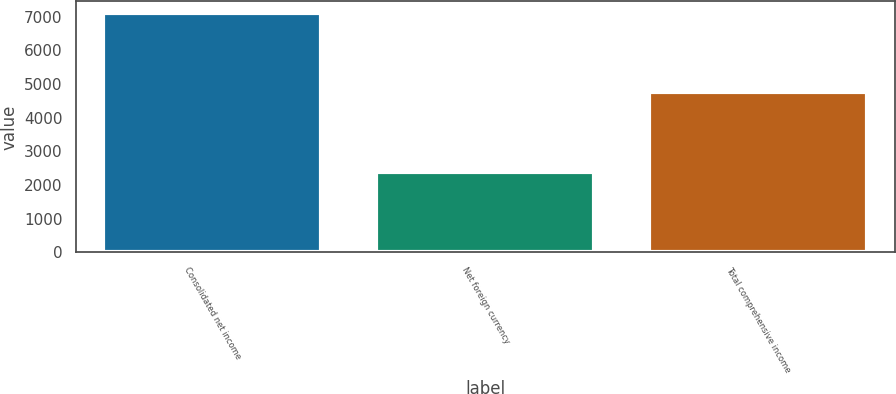Convert chart. <chart><loc_0><loc_0><loc_500><loc_500><bar_chart><fcel>Consolidated net income<fcel>Net foreign currency<fcel>Total comprehensive income<nl><fcel>7098<fcel>2377<fcel>4753<nl></chart> 